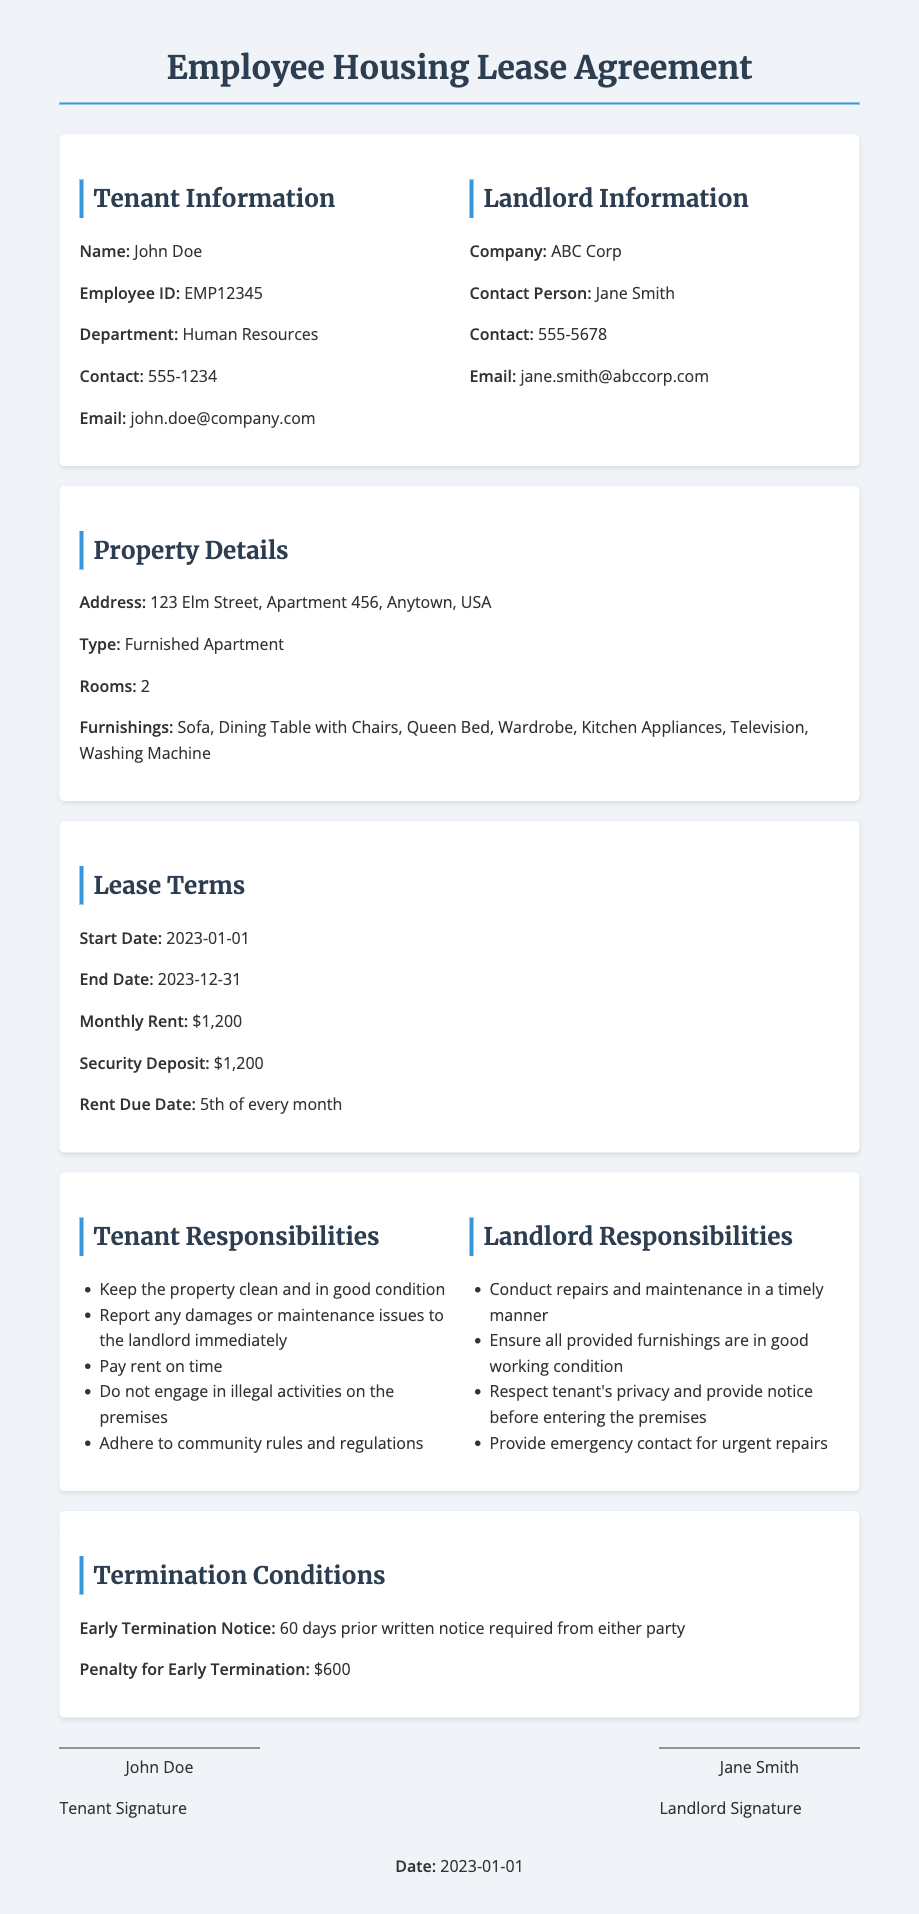What is the tenant's name? The tenant's name is mentioned at the beginning of the document under Tenant Information.
Answer: John Doe What is the monthly rent amount? The monthly rent is specified in the Lease Terms section.
Answer: $1,200 What is the address of the property? The address of the property is found in the Property Details section.
Answer: 123 Elm Street, Apartment 456, Anytown, USA What is the termination notice period? The termination notice period is outlined in the Termination Conditions section.
Answer: 60 days Who is the landlord's contact person? The landlord's contact person is listed under Landlord Information.
Answer: Jane Smith What furnishings are provided? The provided furnishings are detailed in the Property Details section.
Answer: Sofa, Dining Table with Chairs, Queen Bed, Wardrobe, Kitchen Appliances, Television, Washing Machine What is the penalty for early termination? The penalty for early termination is stated under Termination Conditions.
Answer: $600 When does the lease start? The lease start date is specified in the Lease Terms section.
Answer: 2023-01-01 What responsibilities does the tenant have? The tenant responsibilities are documented in the Tenant Responsibilities section.
Answer: Keep the property clean and in good condition 